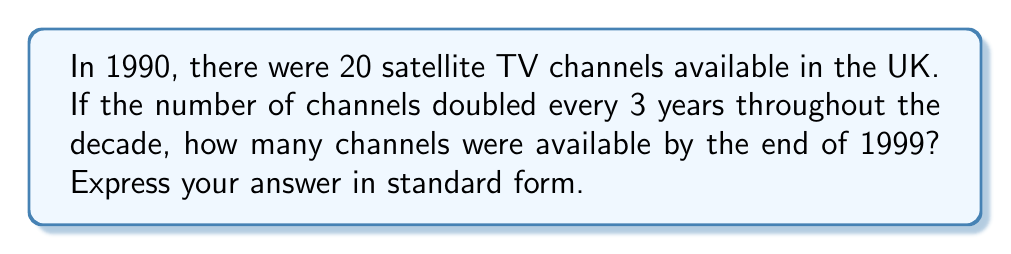Could you help me with this problem? Let's approach this step-by-step:

1) First, we need to determine how many times the number of channels doubled from 1990 to 1999.
   - The period is 9 years (1990 to 1999 inclusive)
   - The doubling occurs every 3 years
   - So, the number of doublings is 9 ÷ 3 = 3

2) We can express this mathematically as:
   $\text{Final number of channels} = 20 \times 2^3$

3) Let's calculate $2^3$:
   $2^3 = 2 \times 2 \times 2 = 8$

4) Now, we can multiply:
   $20 \times 8 = 160$

5) Therefore, by the end of 1999, there were 160 satellite TV channels available.

6) The question asks for the answer in standard form. 160 is already in standard form as it's between 1 and 1000.
Answer: 160 